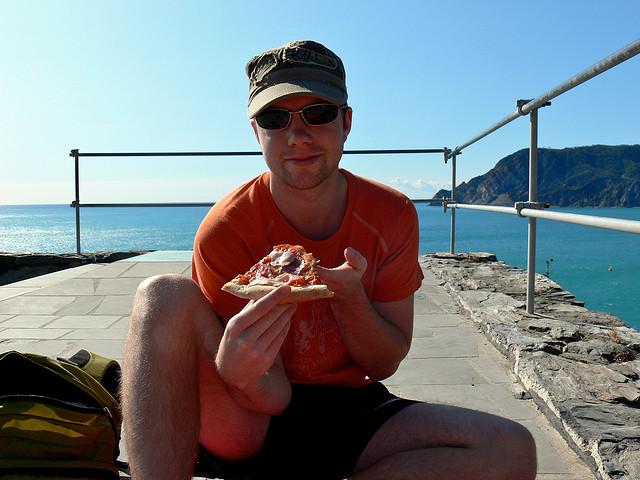What is the person doing?
Concise answer only. Eating pizza. Is this person sitting on the sand?
Answer briefly. No. Is the man wearing sunglasses?
Write a very short answer. Yes. Is this person dry?
Write a very short answer. Yes. 